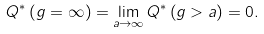Convert formula to latex. <formula><loc_0><loc_0><loc_500><loc_500>Q ^ { * } \left ( g = \infty \right ) = \lim _ { a \rightarrow \infty } Q ^ { * } \left ( g > a \right ) = 0 .</formula> 